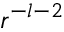<formula> <loc_0><loc_0><loc_500><loc_500>r ^ { - l - 2 }</formula> 